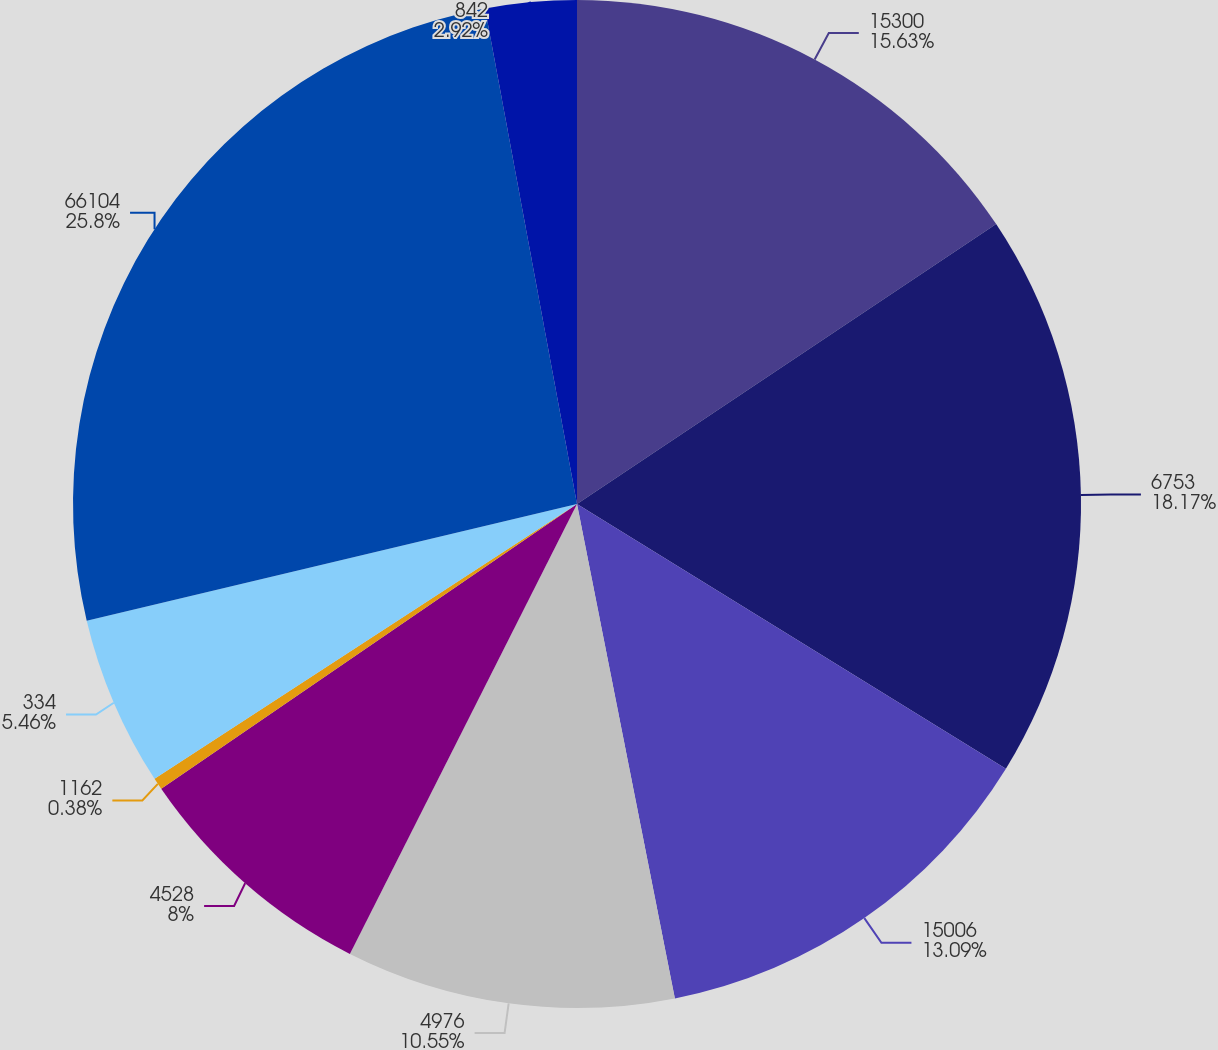Convert chart to OTSL. <chart><loc_0><loc_0><loc_500><loc_500><pie_chart><fcel>15300<fcel>6753<fcel>15006<fcel>4976<fcel>4528<fcel>1162<fcel>334<fcel>66104<fcel>842<nl><fcel>15.63%<fcel>18.17%<fcel>13.09%<fcel>10.55%<fcel>8.0%<fcel>0.38%<fcel>5.46%<fcel>25.8%<fcel>2.92%<nl></chart> 